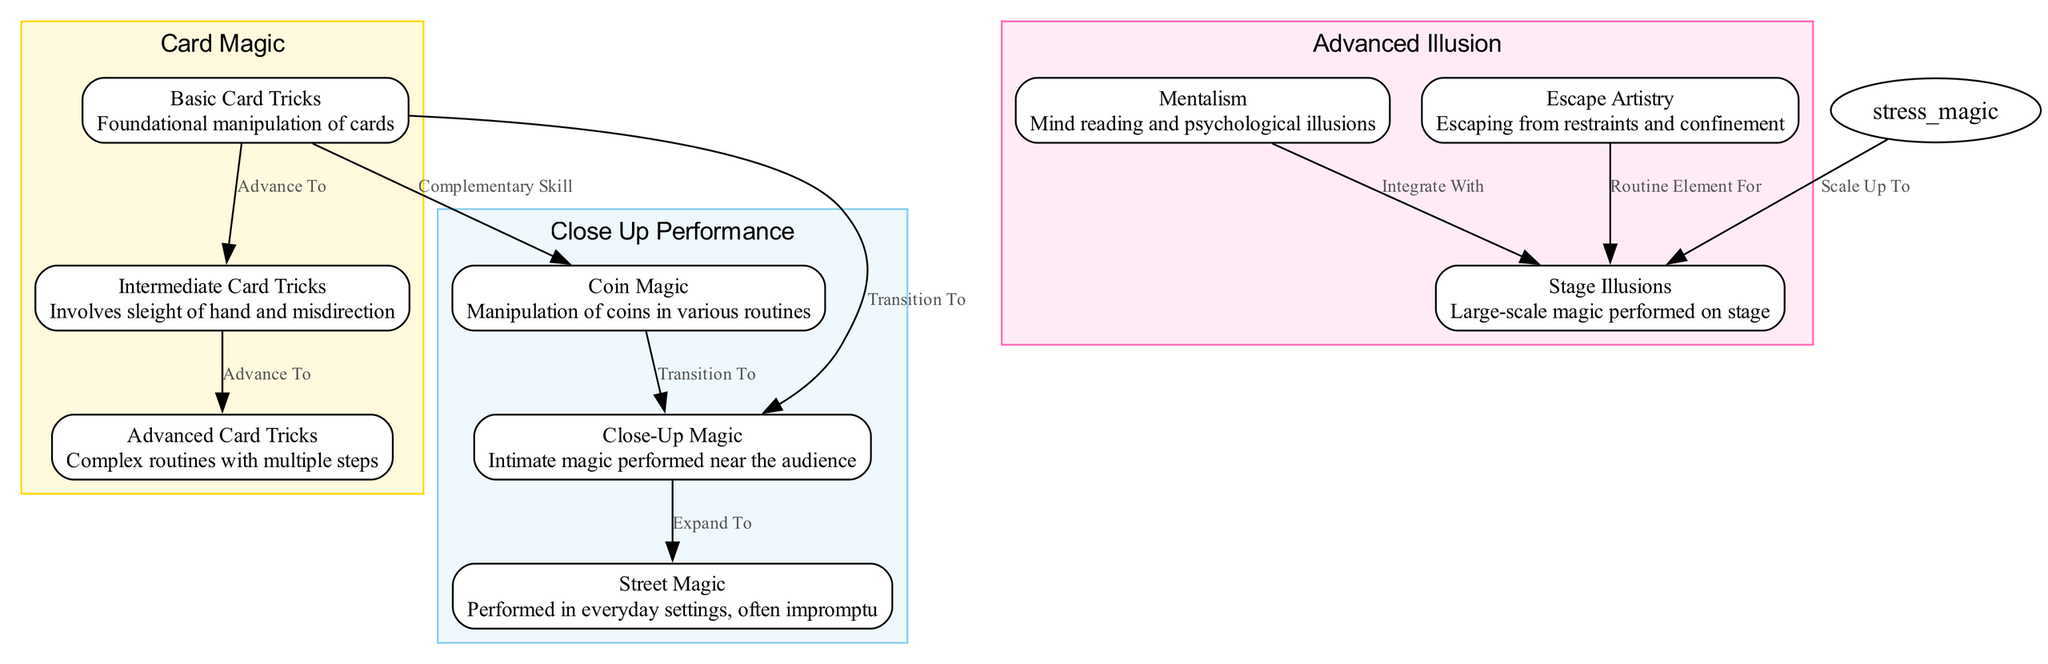What is the total number of nodes in the diagram? The diagram contains a list of nodes, which are defined in the 'nodes' section of the data. There are 9 magic tricks represented as nodes.
Answer: 9 Which cluster contains the trick "Mentalism"? The clusters are defined in the 'clusters' section, and the "Mentalism" trick is included in the cluster identified by "advanced_illusion".
Answer: advanced illusion What type of edge connects "Basic Card Tricks" to "Intermediate Card Tricks"? The relationship between "Basic Card Tricks" and "Intermediate Card Tricks" is indicated by the edges in the 'edges' section. It is labeled as "advance_to".
Answer: advance to How many edges are present in the diagram? The number of relationships (edges) connecting the nodes can be counted in the 'edges' section, which lists 8 unique connections.
Answer: 8 Which skills are considered complementary to "Basic Card Tricks"? According to the edges in the diagram, "coin_magic" is shown as a complementary skill to "basic_card_tricks".
Answer: coin magic What is the progression path from "Close-Up Magic" to "Street Magic"? The edge labeled "expand_to" indicates that "Close-Up Magic" leads to "Street Magic", illustrating the progression from one skill to the next.
Answer: expand to How are "Escape Artistry" and "Stage Illusions" related? The edge connecting "Escape Artistry" to "Stage Illusions" is labeled as "routine_element_for", which signifies that "Escape Artistry" is a part of the routines performed in "Stage Illusions".
Answer: routine element for What color represents the "Close-Up Performance" cluster in the diagram? The cluster color is specified in the code, wherein the "close_up_performance" cluster is assigned the sky blue color (#87CEEB).
Answer: sky blue What clusters are present in the diagram? The diagram defines three clusters: "card_magic", "close_up_performance", and "advanced_illusion", which categorize the different magic tricks based on their characteristics.
Answer: card magic, close up performance, advanced illusion 